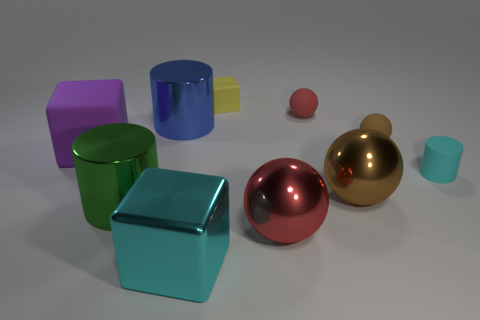What is the material of the red sphere in front of the large object behind the large purple cube?
Your answer should be very brief. Metal. What is the shape of the metallic object that is the same color as the matte cylinder?
Provide a short and direct response. Cube. Are there any small red spheres made of the same material as the big red ball?
Ensure brevity in your answer.  No. Is the material of the large cyan cube the same as the cylinder that is in front of the tiny cyan rubber cylinder?
Provide a succinct answer. Yes. What is the color of the matte cube that is the same size as the rubber cylinder?
Ensure brevity in your answer.  Yellow. What size is the cyan object that is behind the red thing that is in front of the red matte thing?
Give a very brief answer. Small. Does the small matte cylinder have the same color as the large block that is behind the green metallic cylinder?
Make the answer very short. No. Is the number of small blocks in front of the large brown thing less than the number of small green objects?
Make the answer very short. No. What number of other objects are the same size as the cyan cube?
Your answer should be very brief. 5. Do the small thing behind the red matte sphere and the big brown object have the same shape?
Your answer should be compact. No. 